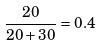Convert formula to latex. <formula><loc_0><loc_0><loc_500><loc_500>\frac { 2 0 } { 2 0 + 3 0 } = 0 . 4</formula> 